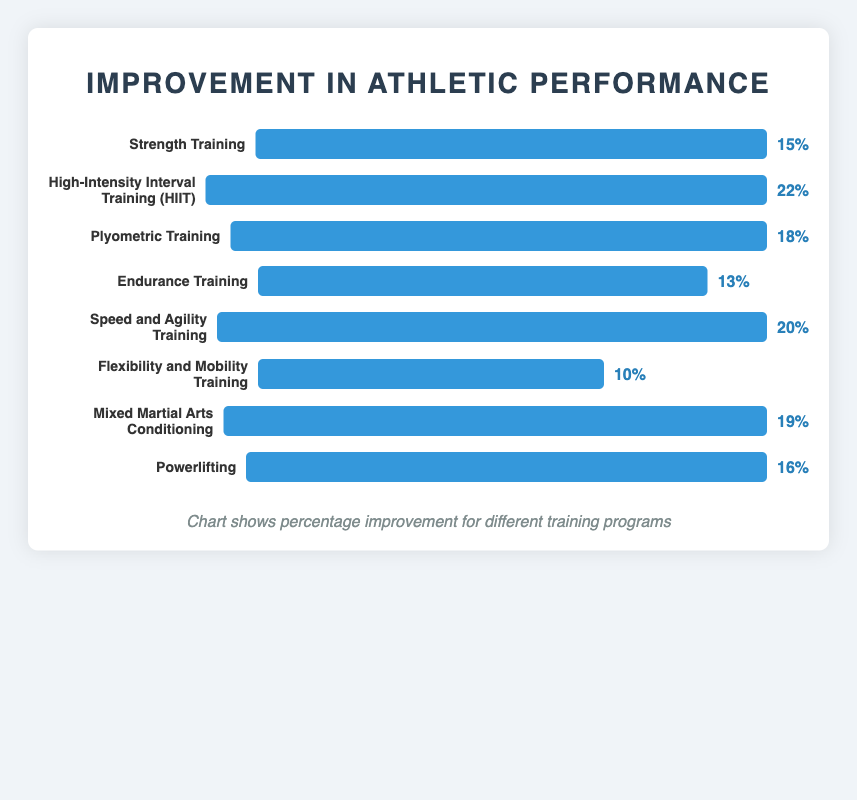What training program shows the highest improvement? The training program with the highest percentage improvement is the tallest bar in the chart. The "High-Intensity Interval Training (HIIT)" bar reaches 22%, which is the highest.
Answer: High-Intensity Interval Training (HIIT) Which training program shows the lowest improvement? The training program with the smallest percentage improvement has the shortest bar in the chart. The "Flexibility and Mobility Training" bar is the shortest at 10%.
Answer: Flexibility and Mobility Training What is the combined improvement percentage of Strength Training and Powerlifting? Add the improvement percentages of "Strength Training" (15%) and "Powerlifting" (16%). The combined total is 15% + 16% = 31%.
Answer: 31% Which training program has a higher improvement percentage, Plyometric Training or Mixed Martial Arts Conditioning? Compare the heights of the bars for "Plyometric Training" (18%) and "Mixed Martial Arts Conditioning" (19%). The bar for "Mixed Martial Arts Conditioning" is slightly higher.
Answer: Mixed Martial Arts Conditioning How much more improvement does Speed and Agility Training have over Endurance Training? Subtract the improvement percentage of "Endurance Training" (13%) from "Speed and Agility Training" (20%). The difference is 20% - 13% = 7%.
Answer: 7% Which training program has the second-highest improvement percentage? Find the bars and percentages on the chart. The second-highest percentage after "High-Intensity Interval Training (HIIT)" (22%) is "Speed and Agility Training" at 20%.
Answer: Speed and Agility Training Calculate the average improvement percentage across all training programs shown. Sum all improvement percentages (15% + 22% + 18% + 13% + 20% + 10% + 19% + 16% = 133%), then divide by the number of programs (8). The average is 133 / 8 = 16.625%.
Answer: 16.625% Which training programs have an improvement of 15% or more? Identify bars with heights corresponding to percentages 15% or higher: "Strength Training" (15%), "High-Intensity Interval Training (HIIT)" (22%), "Plyometric Training" (18%), "Speed and Agility Training" (20%), "Mixed Martial Arts Conditioning" (19%), and "Powerlifting" (16%).
Answer: Strength Training, High-Intensity Interval Training (HIIT), Plyometric Training, Speed and Agility Training, Mixed Martial Arts Conditioning, Powerlifting 